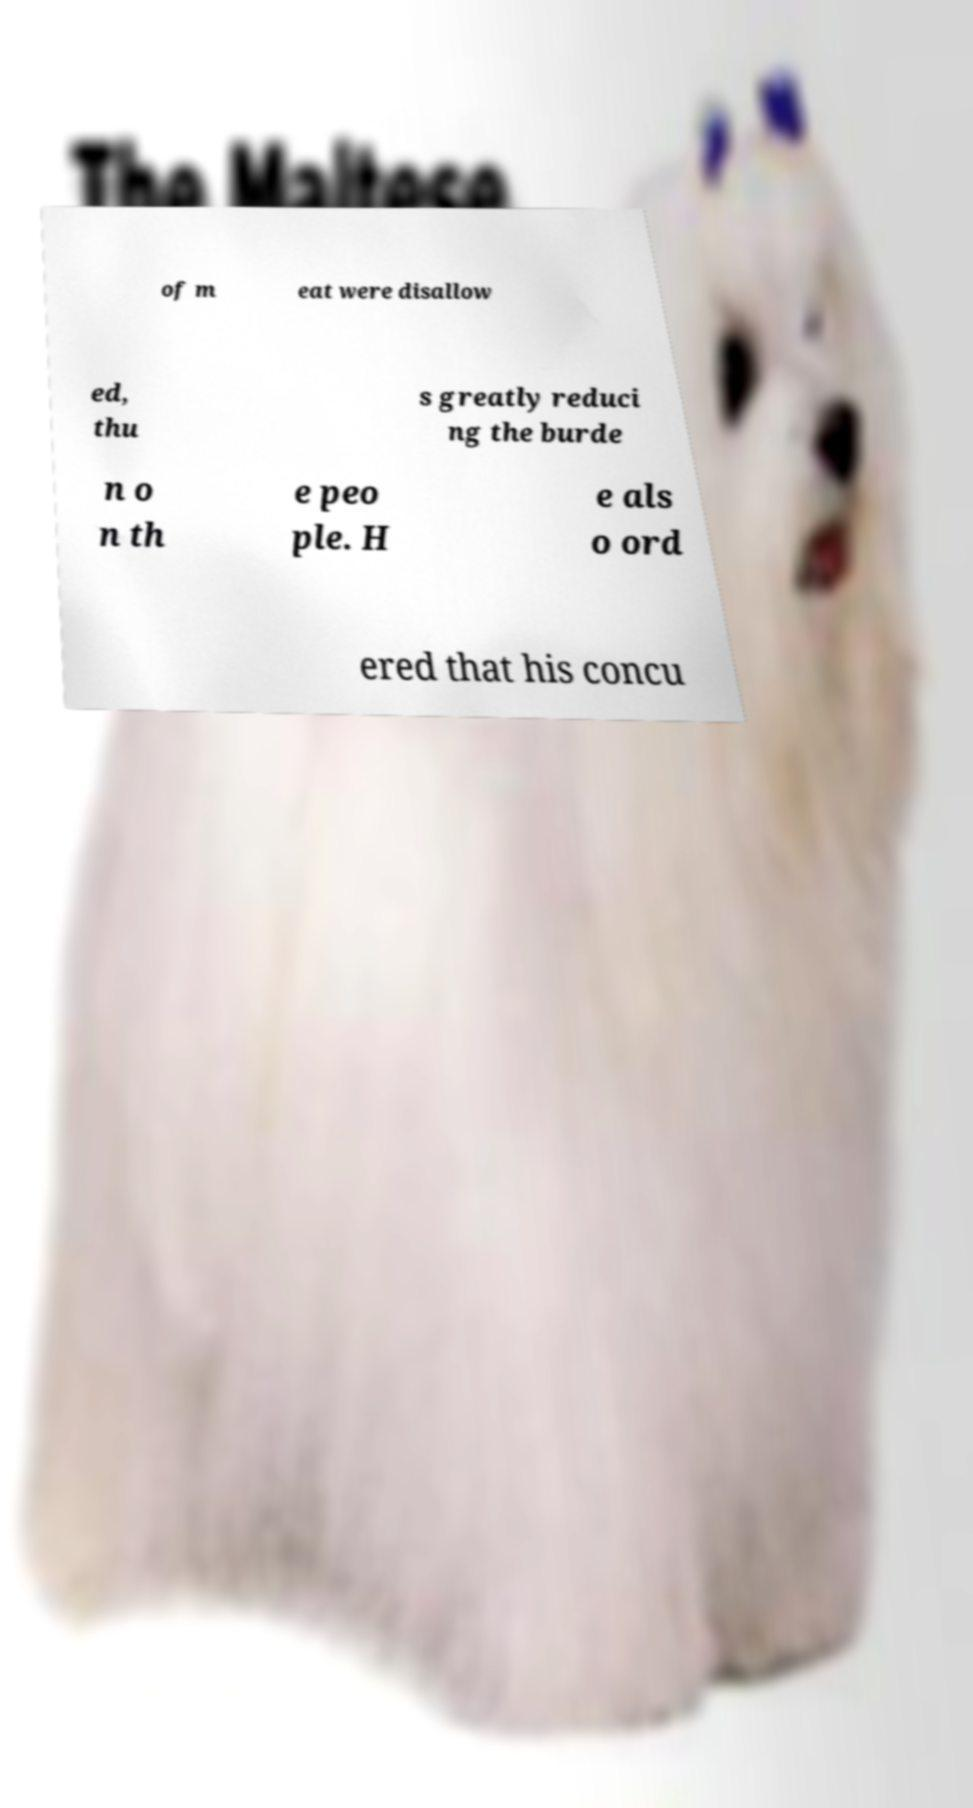Could you assist in decoding the text presented in this image and type it out clearly? of m eat were disallow ed, thu s greatly reduci ng the burde n o n th e peo ple. H e als o ord ered that his concu 